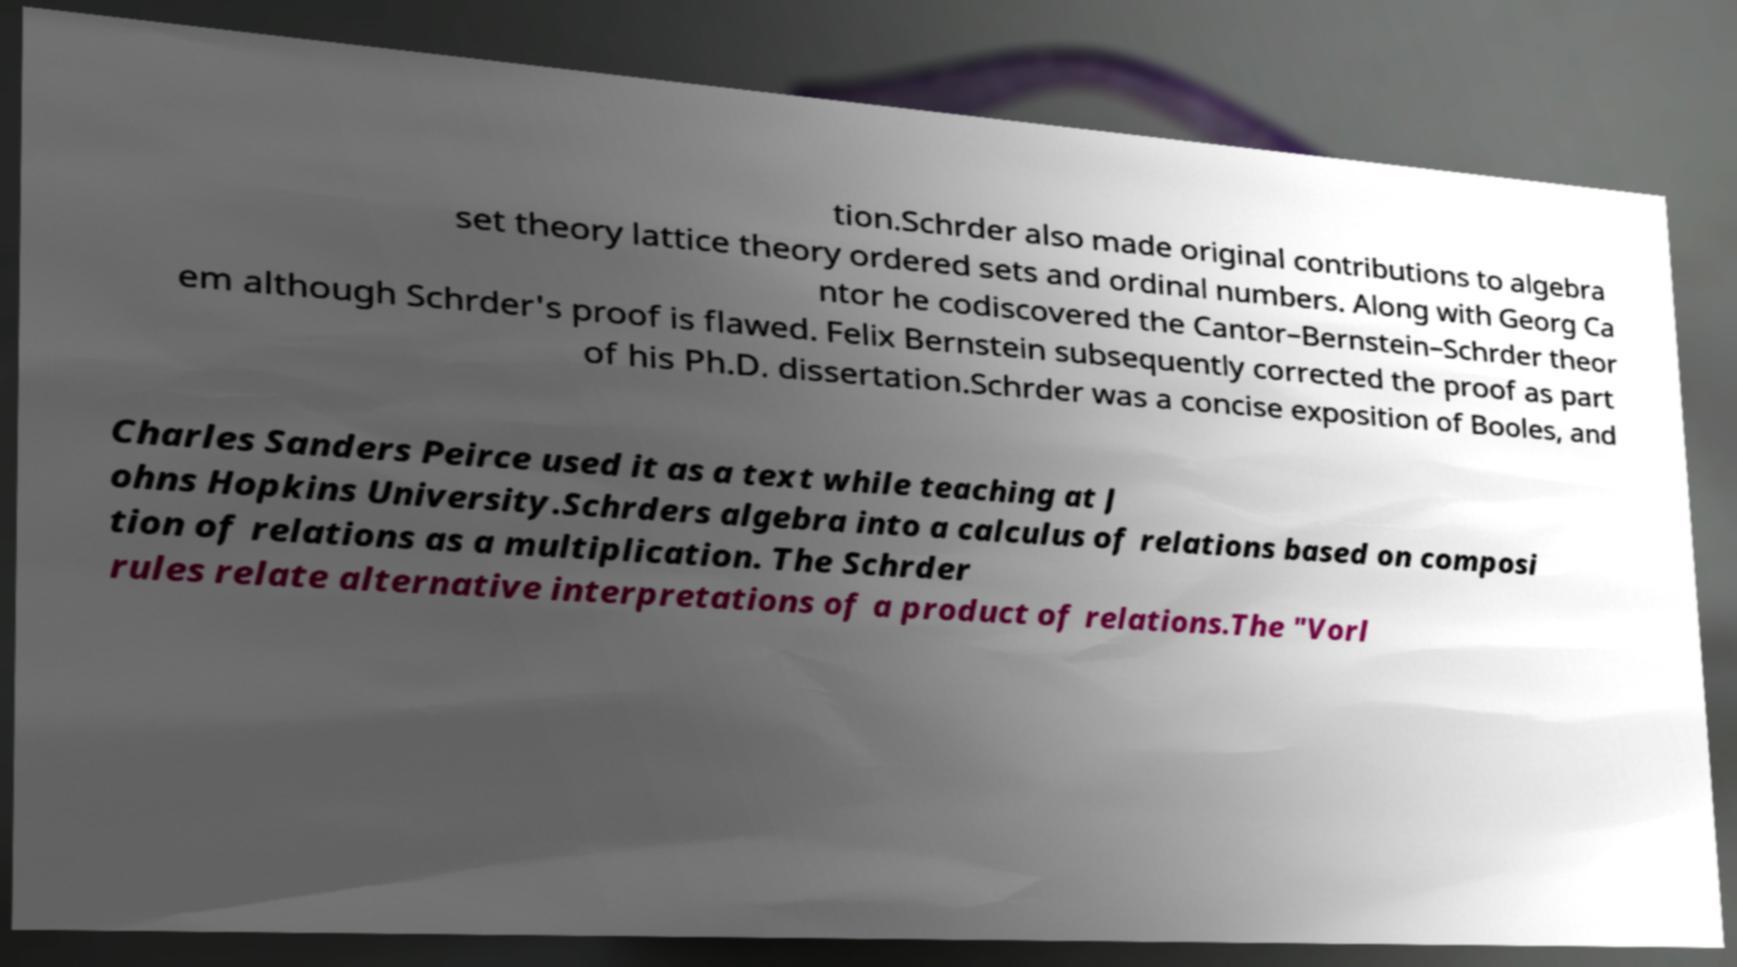For documentation purposes, I need the text within this image transcribed. Could you provide that? tion.Schrder also made original contributions to algebra set theory lattice theory ordered sets and ordinal numbers. Along with Georg Ca ntor he codiscovered the Cantor–Bernstein–Schrder theor em although Schrder's proof is flawed. Felix Bernstein subsequently corrected the proof as part of his Ph.D. dissertation.Schrder was a concise exposition of Booles, and Charles Sanders Peirce used it as a text while teaching at J ohns Hopkins University.Schrders algebra into a calculus of relations based on composi tion of relations as a multiplication. The Schrder rules relate alternative interpretations of a product of relations.The "Vorl 